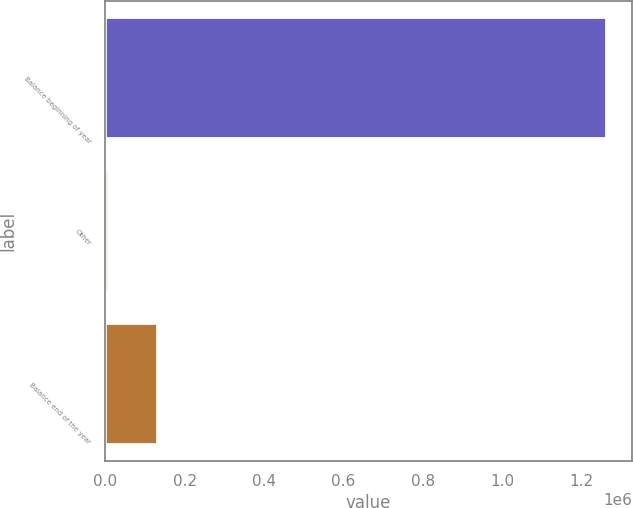Convert chart to OTSL. <chart><loc_0><loc_0><loc_500><loc_500><bar_chart><fcel>Balance beginning of year<fcel>Other<fcel>Balance end of the year<nl><fcel>1.26292e+06<fcel>8481<fcel>133925<nl></chart> 